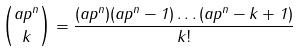<formula> <loc_0><loc_0><loc_500><loc_500>\binom { a p ^ { n } } { k } = \frac { ( a p ^ { n } ) ( a p ^ { n } - 1 ) \dots ( a p ^ { n } - k + 1 ) } { k ! }</formula> 